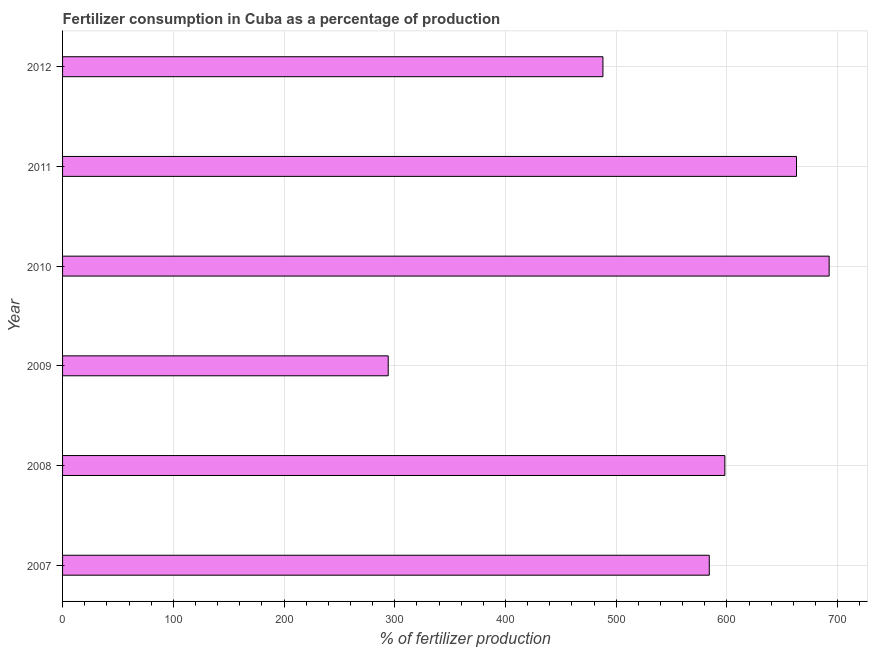Does the graph contain any zero values?
Your response must be concise. No. Does the graph contain grids?
Offer a very short reply. Yes. What is the title of the graph?
Give a very brief answer. Fertilizer consumption in Cuba as a percentage of production. What is the label or title of the X-axis?
Make the answer very short. % of fertilizer production. What is the label or title of the Y-axis?
Keep it short and to the point. Year. What is the amount of fertilizer consumption in 2008?
Provide a succinct answer. 598.17. Across all years, what is the maximum amount of fertilizer consumption?
Your answer should be very brief. 692.4. Across all years, what is the minimum amount of fertilizer consumption?
Offer a terse response. 294.13. In which year was the amount of fertilizer consumption maximum?
Your answer should be very brief. 2010. In which year was the amount of fertilizer consumption minimum?
Give a very brief answer. 2009. What is the sum of the amount of fertilizer consumption?
Make the answer very short. 3319.79. What is the difference between the amount of fertilizer consumption in 2007 and 2008?
Keep it short and to the point. -14.05. What is the average amount of fertilizer consumption per year?
Keep it short and to the point. 553.3. What is the median amount of fertilizer consumption?
Offer a very short reply. 591.14. What is the ratio of the amount of fertilizer consumption in 2007 to that in 2010?
Provide a short and direct response. 0.84. Is the amount of fertilizer consumption in 2008 less than that in 2012?
Provide a short and direct response. No. What is the difference between the highest and the second highest amount of fertilizer consumption?
Provide a short and direct response. 29.48. Is the sum of the amount of fertilizer consumption in 2007 and 2011 greater than the maximum amount of fertilizer consumption across all years?
Provide a succinct answer. Yes. What is the difference between the highest and the lowest amount of fertilizer consumption?
Your answer should be very brief. 398.27. Are all the bars in the graph horizontal?
Your answer should be compact. Yes. How many years are there in the graph?
Your answer should be compact. 6. Are the values on the major ticks of X-axis written in scientific E-notation?
Offer a terse response. No. What is the % of fertilizer production of 2007?
Make the answer very short. 584.11. What is the % of fertilizer production in 2008?
Provide a succinct answer. 598.17. What is the % of fertilizer production in 2009?
Your answer should be very brief. 294.13. What is the % of fertilizer production of 2010?
Provide a succinct answer. 692.4. What is the % of fertilizer production in 2011?
Your answer should be compact. 662.92. What is the % of fertilizer production of 2012?
Your response must be concise. 488.07. What is the difference between the % of fertilizer production in 2007 and 2008?
Provide a succinct answer. -14.05. What is the difference between the % of fertilizer production in 2007 and 2009?
Make the answer very short. 289.99. What is the difference between the % of fertilizer production in 2007 and 2010?
Your response must be concise. -108.28. What is the difference between the % of fertilizer production in 2007 and 2011?
Your answer should be very brief. -78.8. What is the difference between the % of fertilizer production in 2007 and 2012?
Your answer should be very brief. 96.05. What is the difference between the % of fertilizer production in 2008 and 2009?
Your answer should be compact. 304.04. What is the difference between the % of fertilizer production in 2008 and 2010?
Your answer should be compact. -94.23. What is the difference between the % of fertilizer production in 2008 and 2011?
Provide a short and direct response. -64.75. What is the difference between the % of fertilizer production in 2008 and 2012?
Your answer should be compact. 110.1. What is the difference between the % of fertilizer production in 2009 and 2010?
Provide a short and direct response. -398.27. What is the difference between the % of fertilizer production in 2009 and 2011?
Offer a very short reply. -368.79. What is the difference between the % of fertilizer production in 2009 and 2012?
Provide a short and direct response. -193.94. What is the difference between the % of fertilizer production in 2010 and 2011?
Offer a very short reply. 29.48. What is the difference between the % of fertilizer production in 2010 and 2012?
Your answer should be compact. 204.33. What is the difference between the % of fertilizer production in 2011 and 2012?
Your answer should be very brief. 174.85. What is the ratio of the % of fertilizer production in 2007 to that in 2009?
Provide a succinct answer. 1.99. What is the ratio of the % of fertilizer production in 2007 to that in 2010?
Give a very brief answer. 0.84. What is the ratio of the % of fertilizer production in 2007 to that in 2011?
Your answer should be very brief. 0.88. What is the ratio of the % of fertilizer production in 2007 to that in 2012?
Offer a terse response. 1.2. What is the ratio of the % of fertilizer production in 2008 to that in 2009?
Offer a very short reply. 2.03. What is the ratio of the % of fertilizer production in 2008 to that in 2010?
Give a very brief answer. 0.86. What is the ratio of the % of fertilizer production in 2008 to that in 2011?
Your answer should be very brief. 0.9. What is the ratio of the % of fertilizer production in 2008 to that in 2012?
Provide a short and direct response. 1.23. What is the ratio of the % of fertilizer production in 2009 to that in 2010?
Make the answer very short. 0.42. What is the ratio of the % of fertilizer production in 2009 to that in 2011?
Give a very brief answer. 0.44. What is the ratio of the % of fertilizer production in 2009 to that in 2012?
Keep it short and to the point. 0.6. What is the ratio of the % of fertilizer production in 2010 to that in 2011?
Offer a terse response. 1.04. What is the ratio of the % of fertilizer production in 2010 to that in 2012?
Provide a short and direct response. 1.42. What is the ratio of the % of fertilizer production in 2011 to that in 2012?
Your response must be concise. 1.36. 